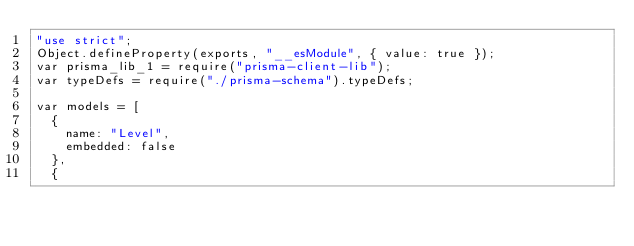<code> <loc_0><loc_0><loc_500><loc_500><_JavaScript_>"use strict";
Object.defineProperty(exports, "__esModule", { value: true });
var prisma_lib_1 = require("prisma-client-lib");
var typeDefs = require("./prisma-schema").typeDefs;

var models = [
  {
    name: "Level",
    embedded: false
  },
  {</code> 